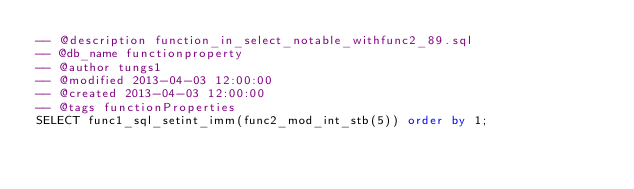Convert code to text. <code><loc_0><loc_0><loc_500><loc_500><_SQL_>-- @description function_in_select_notable_withfunc2_89.sql
-- @db_name functionproperty
-- @author tungs1
-- @modified 2013-04-03 12:00:00
-- @created 2013-04-03 12:00:00
-- @tags functionProperties 
SELECT func1_sql_setint_imm(func2_mod_int_stb(5)) order by 1; 
</code> 